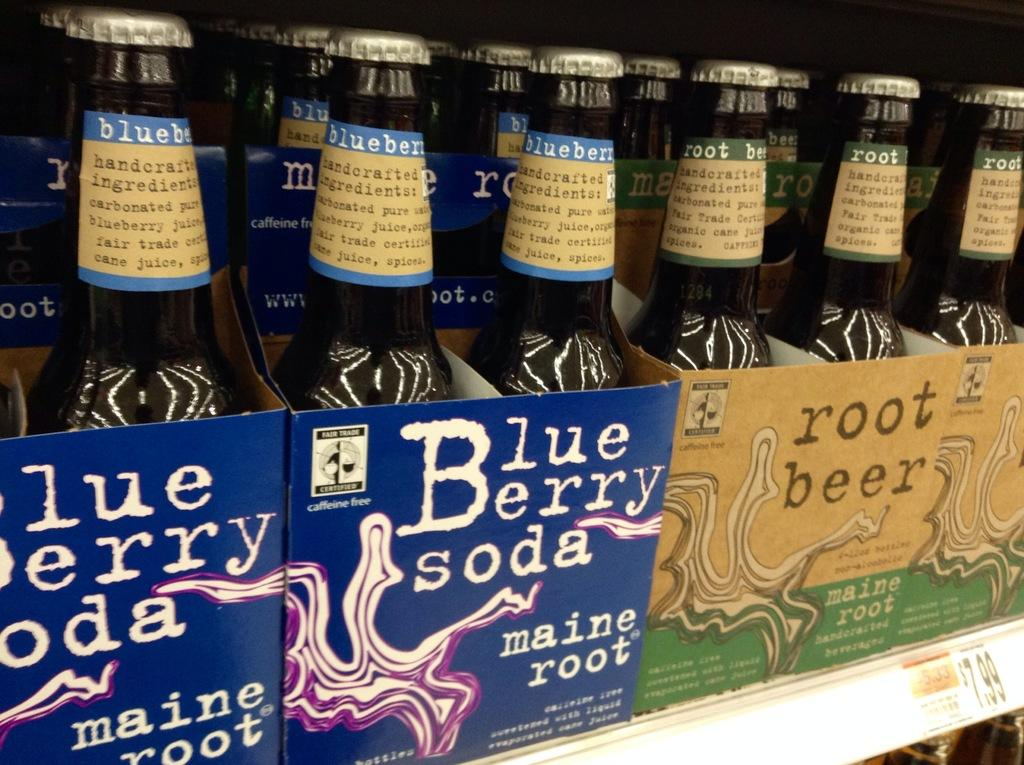<image>
Offer a succinct explanation of the picture presented. Bottles on a shelf one being Blue Berry Soda. 